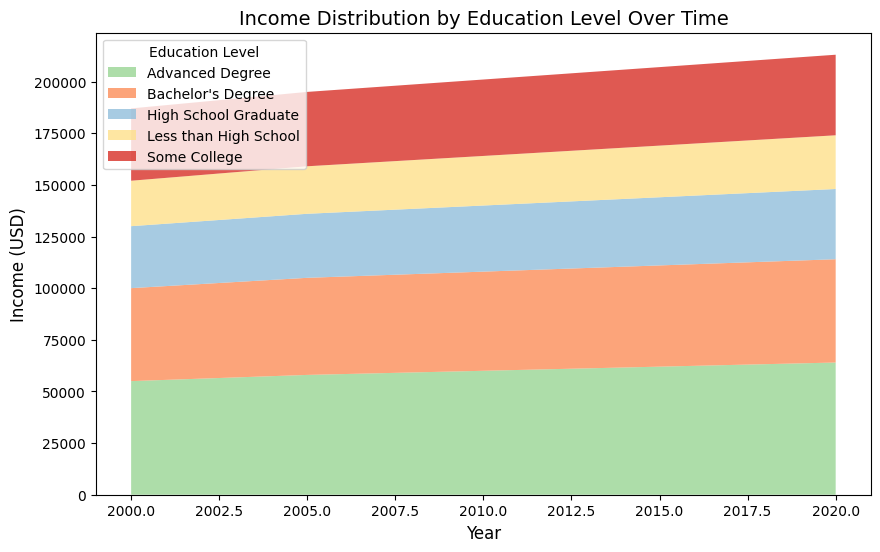Which education level has the highest income in the year 2020? In the year 2020, the highest area in the stackplot corresponds to the income of individuals with an Advanced Degree.
Answer: Advanced Degree What is the total income for the "High School Graduate" group between the years 2000 and 2020? First, find the income for "High School Graduate" in each year: 30000 (2000), 31000 (2005), 32000 (2010), 33000 (2015), 34000 (2020). Add these amounts together: 30000 + 31000 + 32000 + 33000 + 34000 = 160000.
Answer: 160000 By how much did the income of those with a "Some College" education level increase from the year 2000 to 2020? The income for "Some College" is 35000 in 2000 and 39000 in 2020. Subtract the income of 2000 from 2020: 39000 - 35000 = 4000.
Answer: 4000 Which two education levels have the smallest difference in income in 2010, and what is the amount of this difference? In 2010, the incomes are: Less than High School (24000), High School Graduate (32000), Some College (37000), Bachelor's Degree (48000), Advanced Degree (60000). The smallest difference is between "Some College" and "High School Graduate": 37000 - 32000 = 5000.
Answer: Some College and High School Graduate; 5000 What is the average income for individuals with a "Bachelor's Degree" from the years 2000 to 2020? The incomes are: 45000 (2000), 47000 (2005), 48000 (2010), 49000 (2015), 50000 (2020). Calculate their sum: 45000 + 47000 + 48000 + 49000 + 50000 = 239000. Then, divide by the number of data points: 239000 / 5 = 47800.
Answer: 47800 In which year did the income of "Less than High School" education level show the highest increase from the previous recorded year? Check the differences between consecutive years for "Less than High School": 23000 - 22000 (2005-2000) = 1000, 24000 - 23000 (2010-2005) = 1000, 25000 - 24000 (2015-2010) = 1000, 26000 - 25000 (2020-2015) = 1000. The increase is the same each time.
Answer: Each interval has an increase of 1000 Compare the income growth trends between "Bachelor's Degree" and "Advanced Degree" over the period. Which group shows a higher overall increase, and by how much? Calculate the difference in income from 2020 to 2000 for each level: Bachelor's Degree: 50000 - 45000 = 5000, Advanced Degree: 64000 - 55000 = 9000. Advanced Degree shows a higher increase, and the difference is 9000 - 5000 = 4000.
Answer: Advanced Degree; 4000 Which group had the least growth in income from 2000 to 2020? Calculate the income difference between 2020 and 2000 for each group: Less than High School: 26000 - 22000 = 4000, High School Graduate: 34000 - 30000 = 4000, Some College: 39000 - 35000 = 4000, Bachelor's Degree: 50000 - 45000 = 5000, Advanced Degree: 64000 - 55000 = 9000. The least growth is shared by Less than High School, High School Graduate, and Some College, all with 4000.
Answer: Less than High School, High School Graduate, Some College; 4000 What is the income difference between the highest and lowest income education levels in 2015? In 2015, the incomes are: Less than High School (25000), High School Graduate (33000), Some College (38000), Bachelor's Degree (49000), Advanced Degree (62000). Difference: 62000 - 25000 = 37000.
Answer: 37000 What is the visually largest area among all the groups over the entire time span? The largest area visually in the stackplot corresponds to the "Advanced Degree" category, as it consistently remains above other categories with a higher income.
Answer: Advanced Degree 